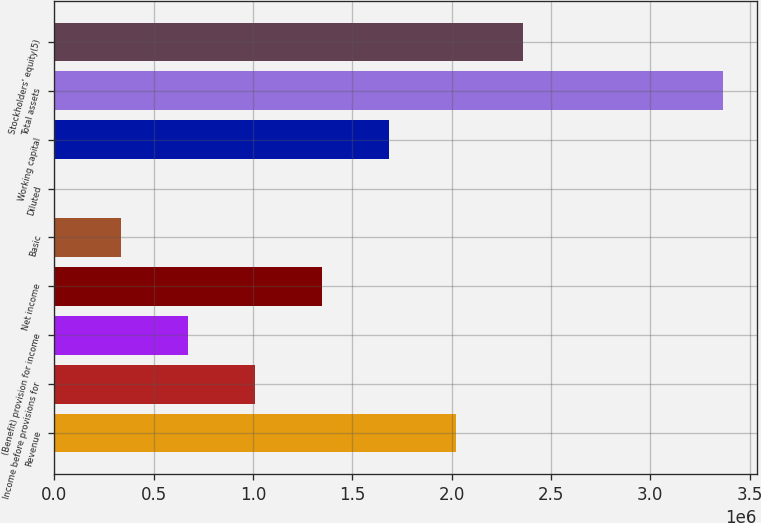Convert chart to OTSL. <chart><loc_0><loc_0><loc_500><loc_500><bar_chart><fcel>Revenue<fcel>Income before provisions for<fcel>(Benefit) provision for income<fcel>Net income<fcel>Basic<fcel>Diluted<fcel>Working capital<fcel>Total assets<fcel>Stockholders' equity(5)<nl><fcel>2.0204e+06<fcel>1.0102e+06<fcel>673468<fcel>1.34693e+06<fcel>336735<fcel>1.47<fcel>1.68367e+06<fcel>3.36733e+06<fcel>2.35713e+06<nl></chart> 